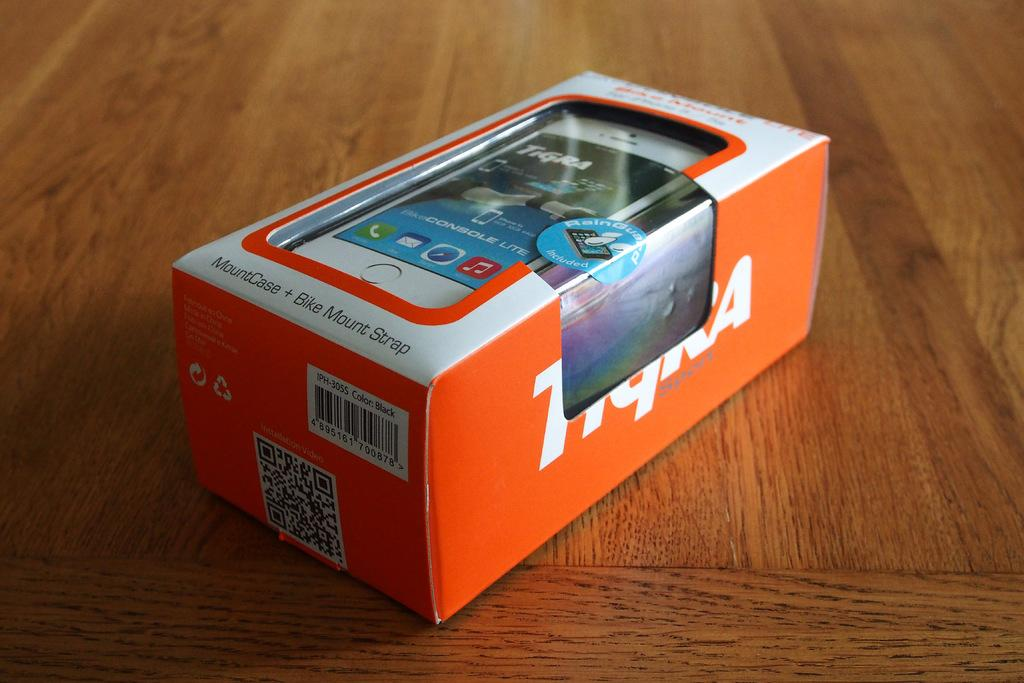<image>
Offer a succinct explanation of the picture presented. A package that contains a MountCase + Bike Mount Strap 